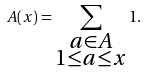Convert formula to latex. <formula><loc_0><loc_0><loc_500><loc_500>A ( x ) = \sum _ { \substack { a \in A \\ 1 \leq a \leq x } } 1 .</formula> 